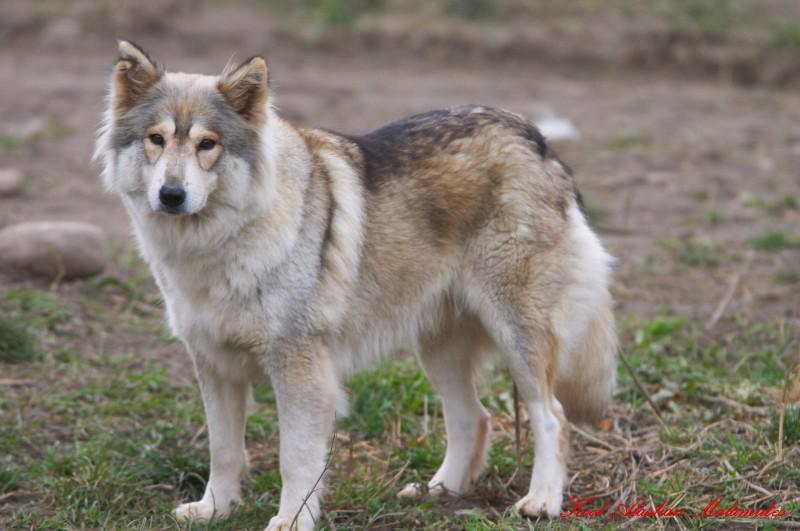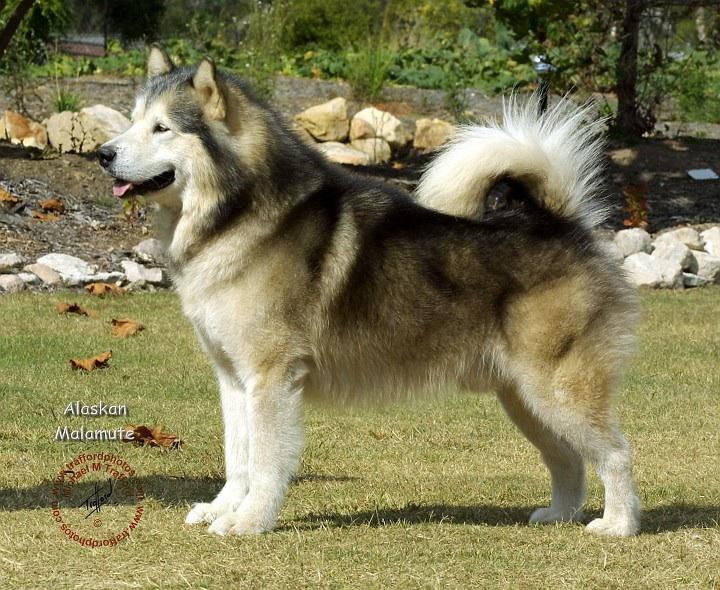The first image is the image on the left, the second image is the image on the right. Evaluate the accuracy of this statement regarding the images: "One image shows a dog standing still in profile facing leftward, with its tail upcurled, and the other image shows a dog with its body turned leftward but its head turned forward and its tail hanging down.". Is it true? Answer yes or no. Yes. The first image is the image on the left, the second image is the image on the right. For the images shown, is this caption "Every photo shows exactly one dog, facing left, photographed outside, and not being accompanied by a human." true? Answer yes or no. Yes. 